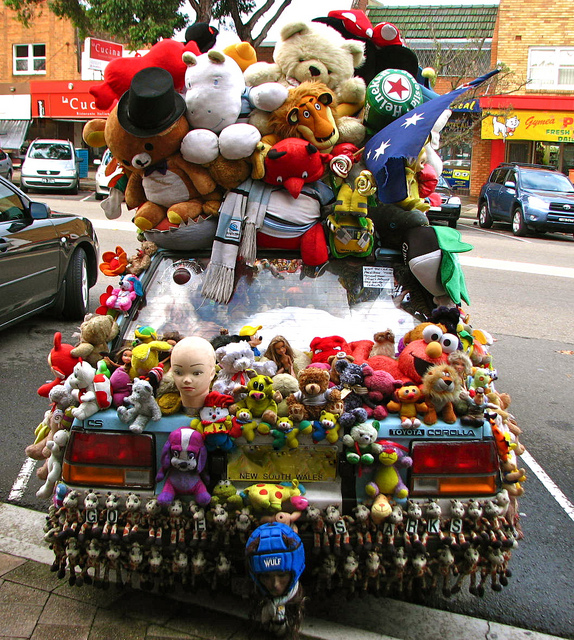Read all the text in this image. TOYOTA COROLLA NEW SOUTH WALES CS E G S K R A S Cucias Cuc FRESH Heinek 